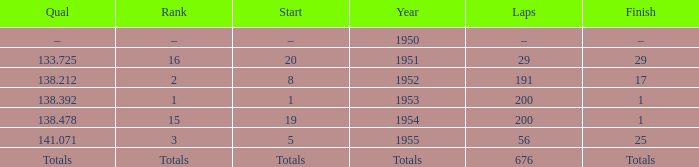How many laps was qualifier of 138.212? 191.0. 